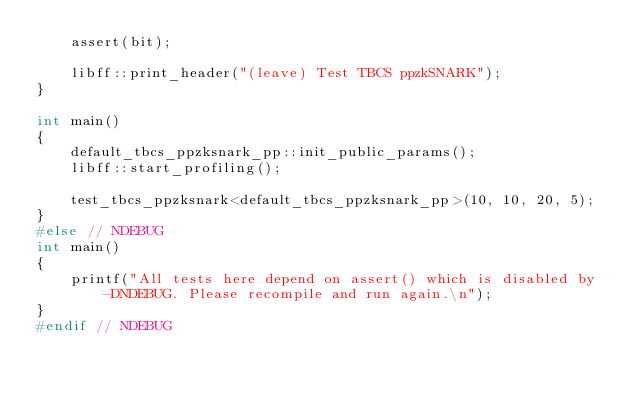Convert code to text. <code><loc_0><loc_0><loc_500><loc_500><_C++_>    assert(bit);

    libff::print_header("(leave) Test TBCS ppzkSNARK");
}

int main()
{
    default_tbcs_ppzksnark_pp::init_public_params();
    libff::start_profiling();

    test_tbcs_ppzksnark<default_tbcs_ppzksnark_pp>(10, 10, 20, 5);
}
#else // NDEBUG
int main()
{
    printf("All tests here depend on assert() which is disabled by -DNDEBUG. Please recompile and run again.\n");
}
#endif // NDEBUG
</code> 